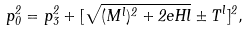Convert formula to latex. <formula><loc_0><loc_0><loc_500><loc_500>p _ { 0 } ^ { 2 } = p _ { 3 } ^ { 2 } + [ \sqrt { ( M ^ { l } ) ^ { 2 } + 2 e H l } \pm T ^ { l } ] ^ { 2 } ,</formula> 